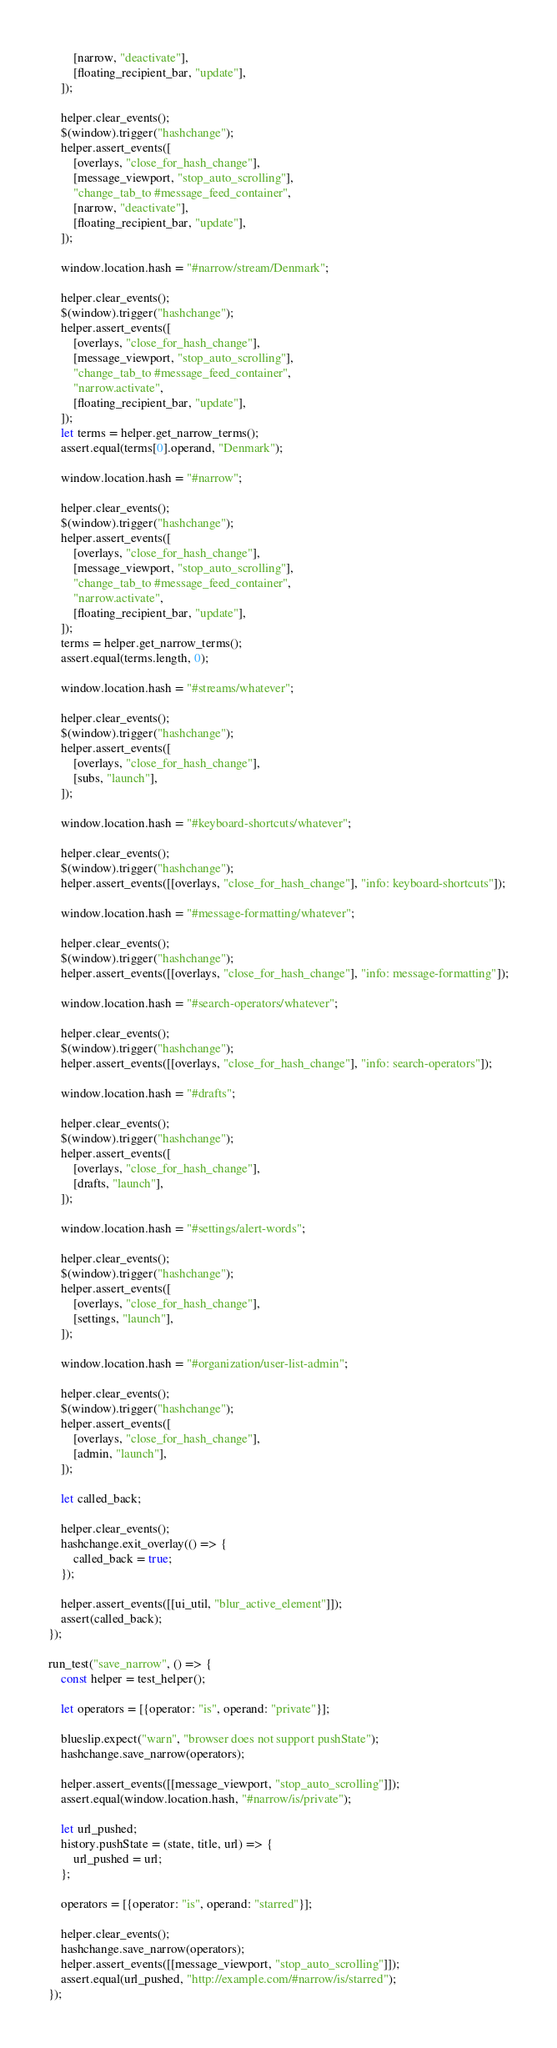Convert code to text. <code><loc_0><loc_0><loc_500><loc_500><_JavaScript_>        [narrow, "deactivate"],
        [floating_recipient_bar, "update"],
    ]);

    helper.clear_events();
    $(window).trigger("hashchange");
    helper.assert_events([
        [overlays, "close_for_hash_change"],
        [message_viewport, "stop_auto_scrolling"],
        "change_tab_to #message_feed_container",
        [narrow, "deactivate"],
        [floating_recipient_bar, "update"],
    ]);

    window.location.hash = "#narrow/stream/Denmark";

    helper.clear_events();
    $(window).trigger("hashchange");
    helper.assert_events([
        [overlays, "close_for_hash_change"],
        [message_viewport, "stop_auto_scrolling"],
        "change_tab_to #message_feed_container",
        "narrow.activate",
        [floating_recipient_bar, "update"],
    ]);
    let terms = helper.get_narrow_terms();
    assert.equal(terms[0].operand, "Denmark");

    window.location.hash = "#narrow";

    helper.clear_events();
    $(window).trigger("hashchange");
    helper.assert_events([
        [overlays, "close_for_hash_change"],
        [message_viewport, "stop_auto_scrolling"],
        "change_tab_to #message_feed_container",
        "narrow.activate",
        [floating_recipient_bar, "update"],
    ]);
    terms = helper.get_narrow_terms();
    assert.equal(terms.length, 0);

    window.location.hash = "#streams/whatever";

    helper.clear_events();
    $(window).trigger("hashchange");
    helper.assert_events([
        [overlays, "close_for_hash_change"],
        [subs, "launch"],
    ]);

    window.location.hash = "#keyboard-shortcuts/whatever";

    helper.clear_events();
    $(window).trigger("hashchange");
    helper.assert_events([[overlays, "close_for_hash_change"], "info: keyboard-shortcuts"]);

    window.location.hash = "#message-formatting/whatever";

    helper.clear_events();
    $(window).trigger("hashchange");
    helper.assert_events([[overlays, "close_for_hash_change"], "info: message-formatting"]);

    window.location.hash = "#search-operators/whatever";

    helper.clear_events();
    $(window).trigger("hashchange");
    helper.assert_events([[overlays, "close_for_hash_change"], "info: search-operators"]);

    window.location.hash = "#drafts";

    helper.clear_events();
    $(window).trigger("hashchange");
    helper.assert_events([
        [overlays, "close_for_hash_change"],
        [drafts, "launch"],
    ]);

    window.location.hash = "#settings/alert-words";

    helper.clear_events();
    $(window).trigger("hashchange");
    helper.assert_events([
        [overlays, "close_for_hash_change"],
        [settings, "launch"],
    ]);

    window.location.hash = "#organization/user-list-admin";

    helper.clear_events();
    $(window).trigger("hashchange");
    helper.assert_events([
        [overlays, "close_for_hash_change"],
        [admin, "launch"],
    ]);

    let called_back;

    helper.clear_events();
    hashchange.exit_overlay(() => {
        called_back = true;
    });

    helper.assert_events([[ui_util, "blur_active_element"]]);
    assert(called_back);
});

run_test("save_narrow", () => {
    const helper = test_helper();

    let operators = [{operator: "is", operand: "private"}];

    blueslip.expect("warn", "browser does not support pushState");
    hashchange.save_narrow(operators);

    helper.assert_events([[message_viewport, "stop_auto_scrolling"]]);
    assert.equal(window.location.hash, "#narrow/is/private");

    let url_pushed;
    history.pushState = (state, title, url) => {
        url_pushed = url;
    };

    operators = [{operator: "is", operand: "starred"}];

    helper.clear_events();
    hashchange.save_narrow(operators);
    helper.assert_events([[message_viewport, "stop_auto_scrolling"]]);
    assert.equal(url_pushed, "http://example.com/#narrow/is/starred");
});
</code> 